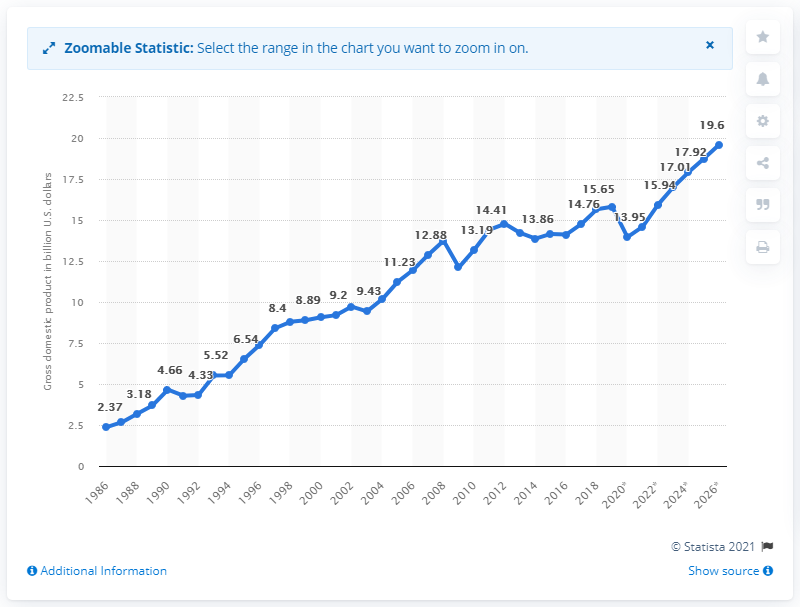Point out several critical features in this image. In 2019, Jamaica's Gross Domestic Product was 15.94. 